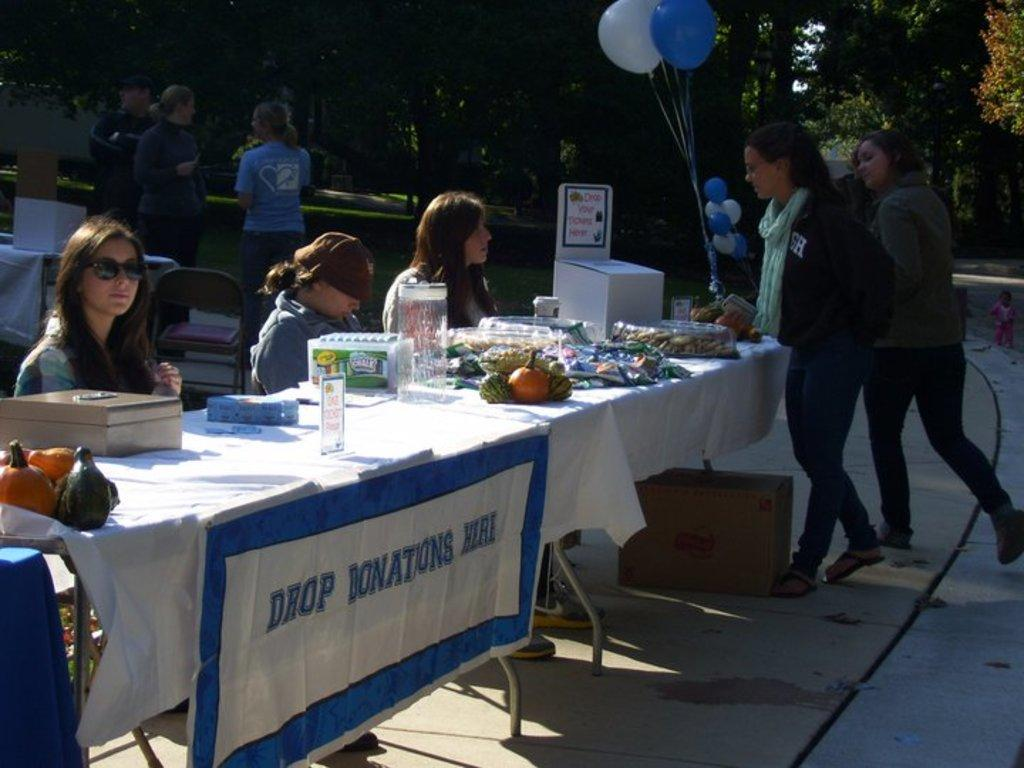How many women are sitting at the table in the image? There are three women sitting at the table in the image. What type of table is depicted in the image? The table is a donation table. Are there any other people approaching the table? Yes, there are two women approaching the table. What type of bat is hanging from the ceiling in the image? There is no bat present in the image; it features three women sitting at a donation table with two women approaching. 